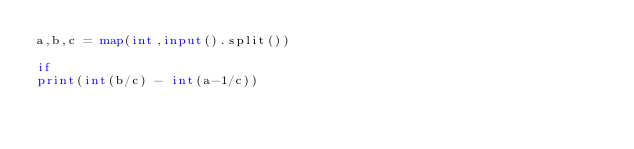<code> <loc_0><loc_0><loc_500><loc_500><_Python_>a,b,c = map(int,input().split())

if 
print(int(b/c) - int(a-1/c))</code> 